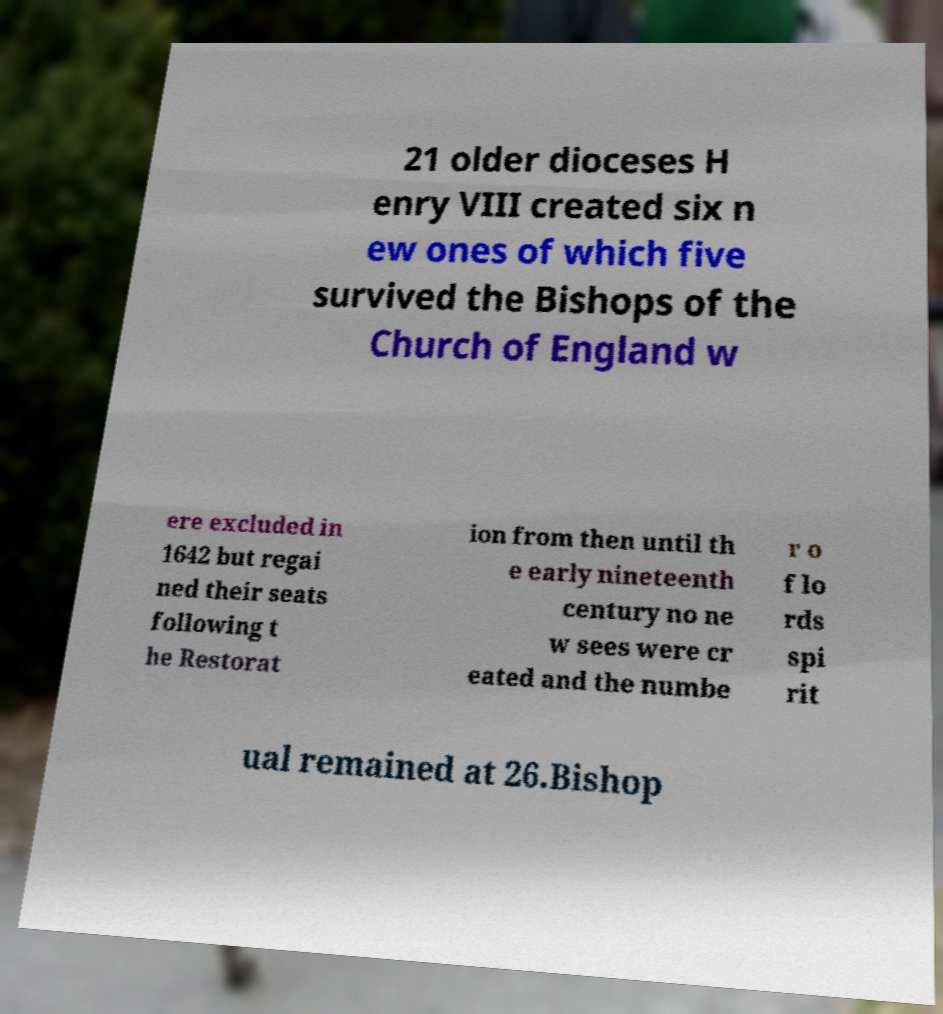Could you assist in decoding the text presented in this image and type it out clearly? 21 older dioceses H enry VIII created six n ew ones of which five survived the Bishops of the Church of England w ere excluded in 1642 but regai ned their seats following t he Restorat ion from then until th e early nineteenth century no ne w sees were cr eated and the numbe r o f lo rds spi rit ual remained at 26.Bishop 